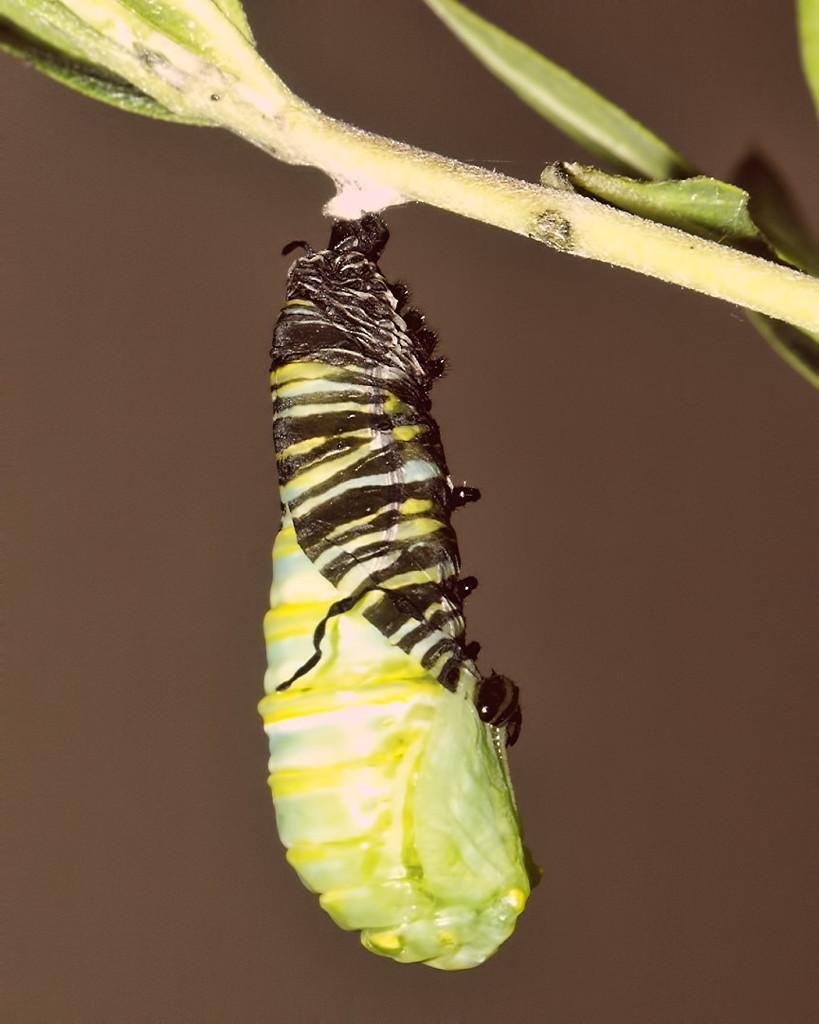Could you give a brief overview of what you see in this image? At the top of this image, there is a plant having leaves. In the middle of this image, there is an insect attached to this plant. And the background is in gray and brown color combination. 